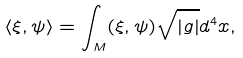<formula> <loc_0><loc_0><loc_500><loc_500>\langle \xi , \psi \rangle = \int _ { M } ( \xi , \psi ) \sqrt { | g | } d ^ { 4 } x ,</formula> 